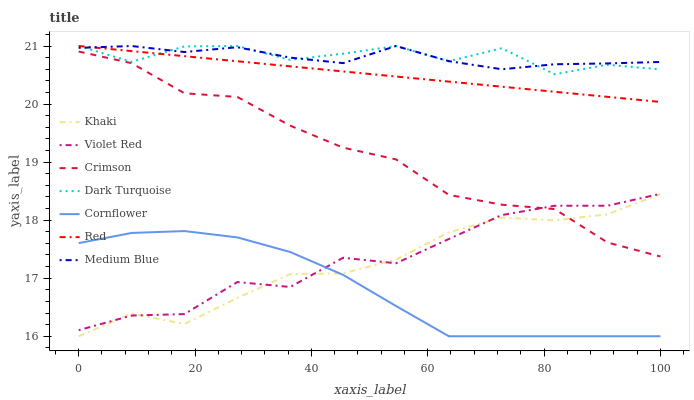Does Cornflower have the minimum area under the curve?
Answer yes or no. Yes. Does Dark Turquoise have the maximum area under the curve?
Answer yes or no. Yes. Does Violet Red have the minimum area under the curve?
Answer yes or no. No. Does Violet Red have the maximum area under the curve?
Answer yes or no. No. Is Red the smoothest?
Answer yes or no. Yes. Is Dark Turquoise the roughest?
Answer yes or no. Yes. Is Violet Red the smoothest?
Answer yes or no. No. Is Violet Red the roughest?
Answer yes or no. No. Does Cornflower have the lowest value?
Answer yes or no. Yes. Does Violet Red have the lowest value?
Answer yes or no. No. Does Red have the highest value?
Answer yes or no. Yes. Does Violet Red have the highest value?
Answer yes or no. No. Is Crimson less than Dark Turquoise?
Answer yes or no. Yes. Is Red greater than Violet Red?
Answer yes or no. Yes. Does Red intersect Medium Blue?
Answer yes or no. Yes. Is Red less than Medium Blue?
Answer yes or no. No. Is Red greater than Medium Blue?
Answer yes or no. No. Does Crimson intersect Dark Turquoise?
Answer yes or no. No. 